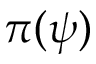<formula> <loc_0><loc_0><loc_500><loc_500>\pi ( \psi )</formula> 